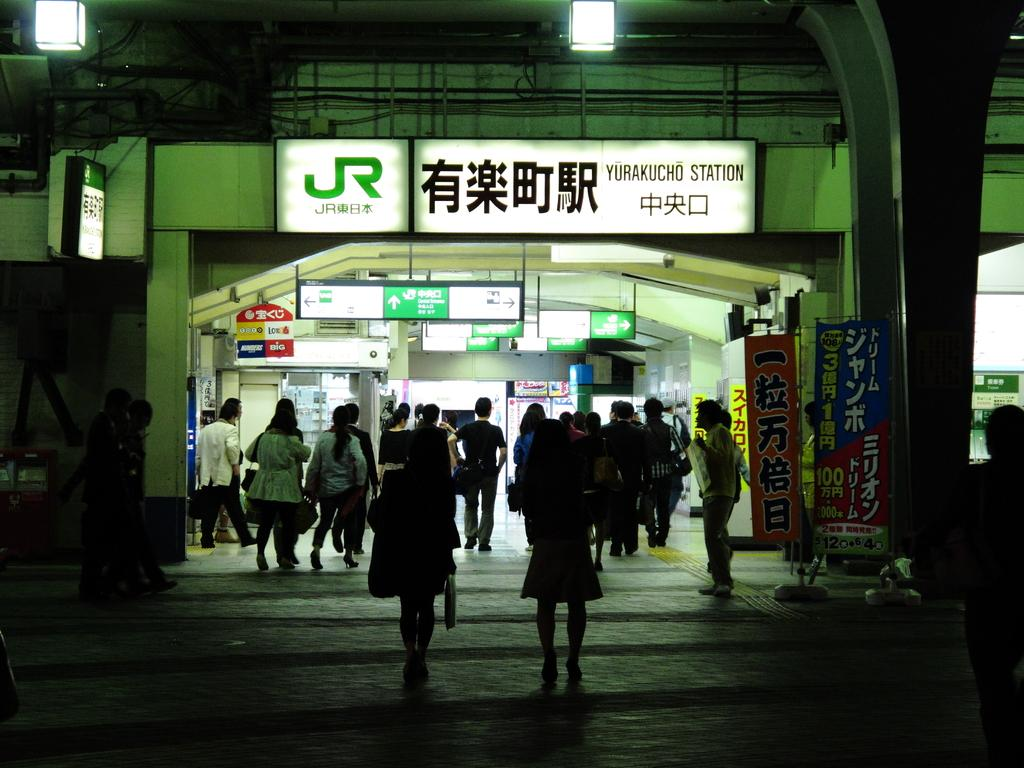<image>
Summarize the visual content of the image. Yurakucho Station is shown with many signs and many people entering. 